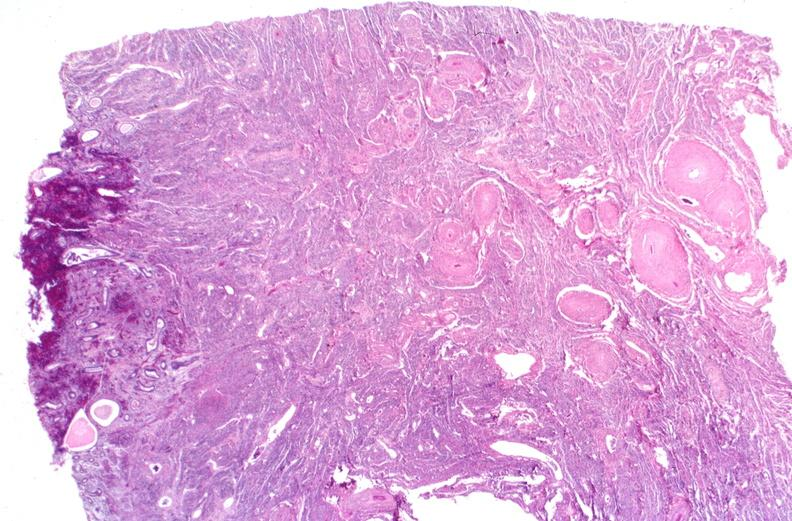does myocardium show kidney, polyarteritis nodosa?
Answer the question using a single word or phrase. No 